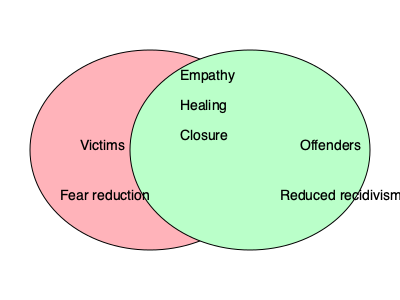Based on the Venn diagram, which psychological effect is shared by both victims and offenders in restorative justice programs? To answer this question, we need to analyze the Venn diagram carefully:

1. The diagram shows two overlapping circles, representing victims and offenders in restorative justice programs.

2. The left circle (pink) represents victims, while the right circle (green) represents offenders.

3. The overlapping area in the middle represents shared effects experienced by both victims and offenders.

4. We can see that "Fear reduction" is listed only in the victims' circle, and "Reduced recidivism" is listed only in the offenders' circle.

5. However, there are three effects listed in the overlapping area: Empathy, Healing, and Closure.

6. These three effects in the overlapping area are shared by both victims and offenders, as they appear in both circles.

Therefore, the psychological effects shared by both victims and offenders in restorative justice programs, according to this Venn diagram, are empathy, healing, and closure.
Answer: Empathy, healing, and closure 